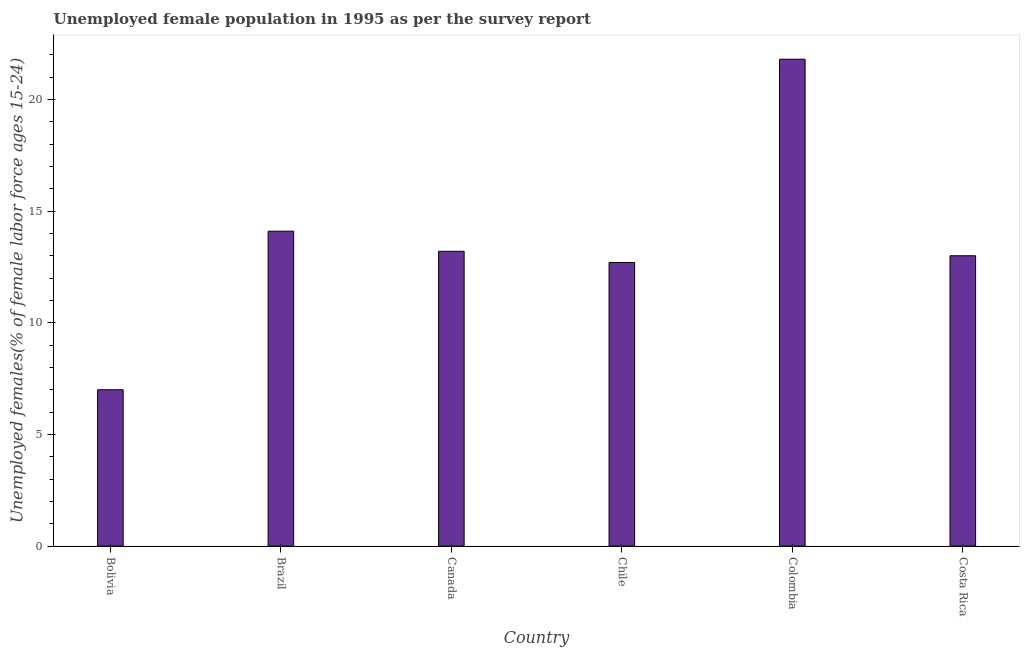Does the graph contain any zero values?
Offer a terse response. No. Does the graph contain grids?
Offer a terse response. No. What is the title of the graph?
Offer a terse response. Unemployed female population in 1995 as per the survey report. What is the label or title of the X-axis?
Give a very brief answer. Country. What is the label or title of the Y-axis?
Offer a very short reply. Unemployed females(% of female labor force ages 15-24). Across all countries, what is the maximum unemployed female youth?
Make the answer very short. 21.8. Across all countries, what is the minimum unemployed female youth?
Your response must be concise. 7. What is the sum of the unemployed female youth?
Your answer should be compact. 81.8. What is the difference between the unemployed female youth in Canada and Costa Rica?
Your answer should be very brief. 0.2. What is the average unemployed female youth per country?
Your answer should be compact. 13.63. What is the median unemployed female youth?
Make the answer very short. 13.1. In how many countries, is the unemployed female youth greater than 3 %?
Keep it short and to the point. 6. What is the ratio of the unemployed female youth in Canada to that in Chile?
Give a very brief answer. 1.04. Is the sum of the unemployed female youth in Bolivia and Brazil greater than the maximum unemployed female youth across all countries?
Your answer should be very brief. No. What is the difference between the highest and the lowest unemployed female youth?
Keep it short and to the point. 14.8. How many bars are there?
Make the answer very short. 6. Are all the bars in the graph horizontal?
Give a very brief answer. No. How many countries are there in the graph?
Make the answer very short. 6. Are the values on the major ticks of Y-axis written in scientific E-notation?
Provide a succinct answer. No. What is the Unemployed females(% of female labor force ages 15-24) of Brazil?
Give a very brief answer. 14.1. What is the Unemployed females(% of female labor force ages 15-24) in Canada?
Keep it short and to the point. 13.2. What is the Unemployed females(% of female labor force ages 15-24) in Chile?
Your response must be concise. 12.7. What is the Unemployed females(% of female labor force ages 15-24) of Colombia?
Your answer should be compact. 21.8. What is the difference between the Unemployed females(% of female labor force ages 15-24) in Bolivia and Brazil?
Provide a succinct answer. -7.1. What is the difference between the Unemployed females(% of female labor force ages 15-24) in Bolivia and Colombia?
Give a very brief answer. -14.8. What is the difference between the Unemployed females(% of female labor force ages 15-24) in Bolivia and Costa Rica?
Your response must be concise. -6. What is the difference between the Unemployed females(% of female labor force ages 15-24) in Brazil and Canada?
Offer a terse response. 0.9. What is the difference between the Unemployed females(% of female labor force ages 15-24) in Brazil and Chile?
Your answer should be very brief. 1.4. What is the difference between the Unemployed females(% of female labor force ages 15-24) in Brazil and Costa Rica?
Offer a terse response. 1.1. What is the difference between the Unemployed females(% of female labor force ages 15-24) in Canada and Chile?
Keep it short and to the point. 0.5. What is the difference between the Unemployed females(% of female labor force ages 15-24) in Canada and Colombia?
Keep it short and to the point. -8.6. What is the difference between the Unemployed females(% of female labor force ages 15-24) in Chile and Colombia?
Ensure brevity in your answer.  -9.1. What is the difference between the Unemployed females(% of female labor force ages 15-24) in Chile and Costa Rica?
Offer a very short reply. -0.3. What is the ratio of the Unemployed females(% of female labor force ages 15-24) in Bolivia to that in Brazil?
Your response must be concise. 0.5. What is the ratio of the Unemployed females(% of female labor force ages 15-24) in Bolivia to that in Canada?
Your response must be concise. 0.53. What is the ratio of the Unemployed females(% of female labor force ages 15-24) in Bolivia to that in Chile?
Provide a succinct answer. 0.55. What is the ratio of the Unemployed females(% of female labor force ages 15-24) in Bolivia to that in Colombia?
Your response must be concise. 0.32. What is the ratio of the Unemployed females(% of female labor force ages 15-24) in Bolivia to that in Costa Rica?
Offer a very short reply. 0.54. What is the ratio of the Unemployed females(% of female labor force ages 15-24) in Brazil to that in Canada?
Make the answer very short. 1.07. What is the ratio of the Unemployed females(% of female labor force ages 15-24) in Brazil to that in Chile?
Your answer should be very brief. 1.11. What is the ratio of the Unemployed females(% of female labor force ages 15-24) in Brazil to that in Colombia?
Offer a terse response. 0.65. What is the ratio of the Unemployed females(% of female labor force ages 15-24) in Brazil to that in Costa Rica?
Keep it short and to the point. 1.08. What is the ratio of the Unemployed females(% of female labor force ages 15-24) in Canada to that in Chile?
Your answer should be very brief. 1.04. What is the ratio of the Unemployed females(% of female labor force ages 15-24) in Canada to that in Colombia?
Your response must be concise. 0.61. What is the ratio of the Unemployed females(% of female labor force ages 15-24) in Chile to that in Colombia?
Give a very brief answer. 0.58. What is the ratio of the Unemployed females(% of female labor force ages 15-24) in Chile to that in Costa Rica?
Offer a very short reply. 0.98. What is the ratio of the Unemployed females(% of female labor force ages 15-24) in Colombia to that in Costa Rica?
Keep it short and to the point. 1.68. 